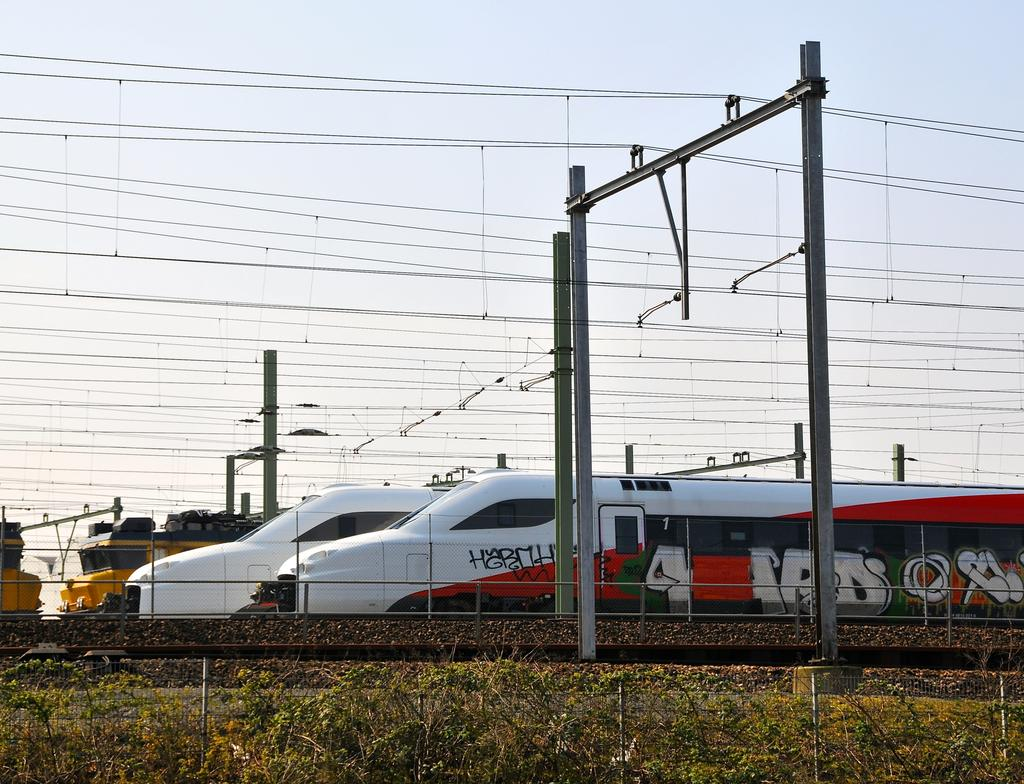What type of vehicles can be seen on the train tracks in the image? There are trains on the train tracks in the image. What structures are present near the train tracks? Electric poles are visible in the image. What is connected to the electric poles? Electric wires are present in the image. What type of barrier is present in the image? There is a fence in the image. What is visible above the train tracks and other elements in the image? The sky is visible in the image. What type of celery is growing near the train tracks in the image? There is no celery present in the image. How does the land look like in the image? The image does not focus on the land, but rather on the trains, train tracks, and other structures. 